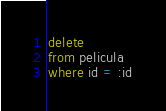Convert code to text. <code><loc_0><loc_0><loc_500><loc_500><_SQL_>delete 
from pelicula
where id = :id</code> 